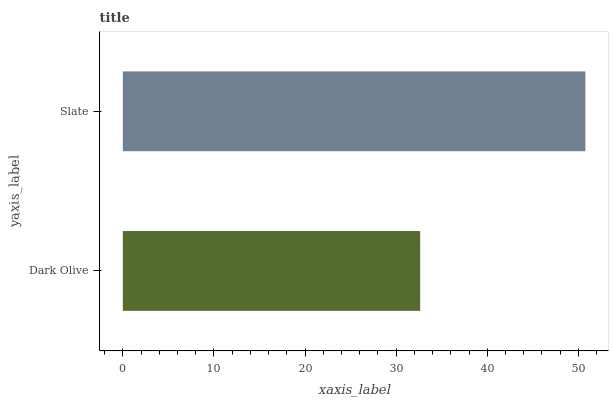Is Dark Olive the minimum?
Answer yes or no. Yes. Is Slate the maximum?
Answer yes or no. Yes. Is Slate the minimum?
Answer yes or no. No. Is Slate greater than Dark Olive?
Answer yes or no. Yes. Is Dark Olive less than Slate?
Answer yes or no. Yes. Is Dark Olive greater than Slate?
Answer yes or no. No. Is Slate less than Dark Olive?
Answer yes or no. No. Is Slate the high median?
Answer yes or no. Yes. Is Dark Olive the low median?
Answer yes or no. Yes. Is Dark Olive the high median?
Answer yes or no. No. Is Slate the low median?
Answer yes or no. No. 